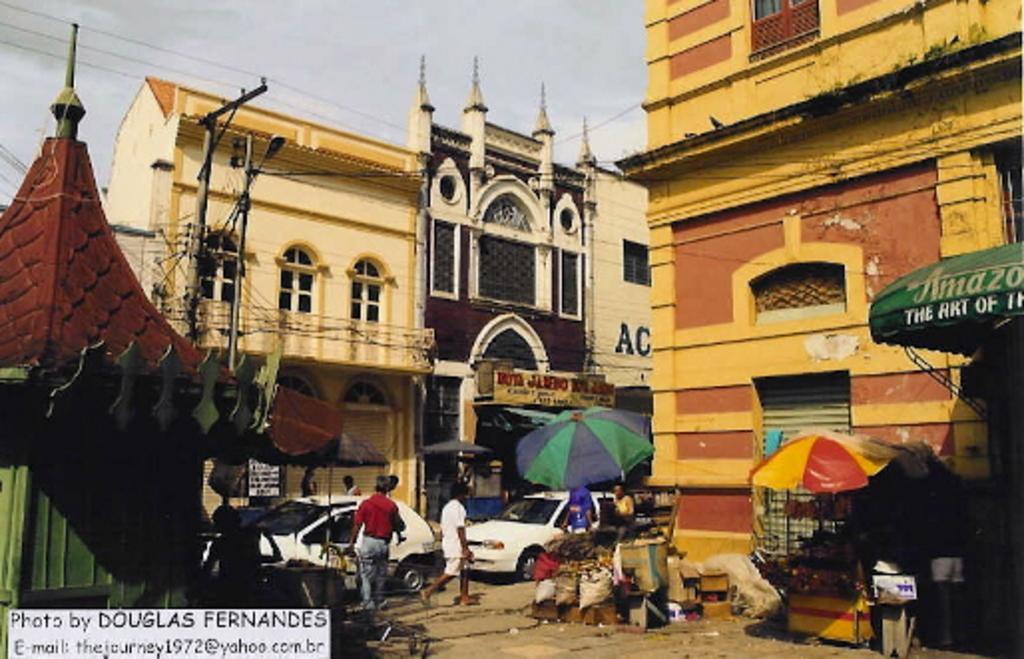Describe this image in one or two sentences. In this picture there are buildings on the right and left side of the image and there are stalls on the right side of the image, there are cars in the center of the image, it seems to be the market place. 